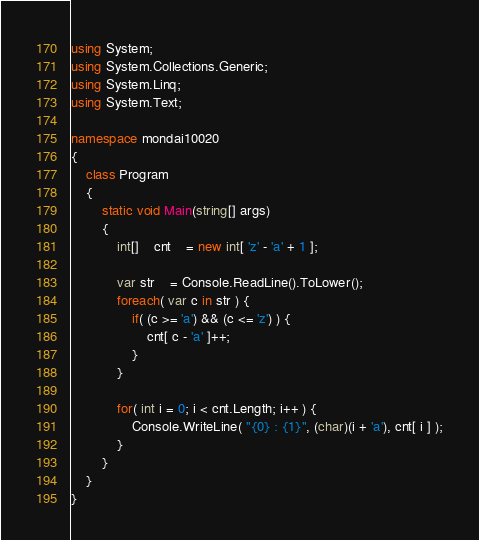<code> <loc_0><loc_0><loc_500><loc_500><_C#_>using System;
using System.Collections.Generic;
using System.Linq;
using System.Text;

namespace mondai10020
{
	class Program
	{
		static void Main(string[] args)
		{
			int[]	cnt	= new int[ 'z' - 'a' + 1 ];

			var str	= Console.ReadLine().ToLower();
			foreach( var c in str ) {
				if( (c >= 'a') && (c <= 'z') ) {
					cnt[ c - 'a' ]++;
				}
			}
			
			for( int i = 0; i < cnt.Length; i++ ) {
				Console.WriteLine( "{0} : {1}", (char)(i + 'a'), cnt[ i ] );
			}
		}
	}
}</code> 